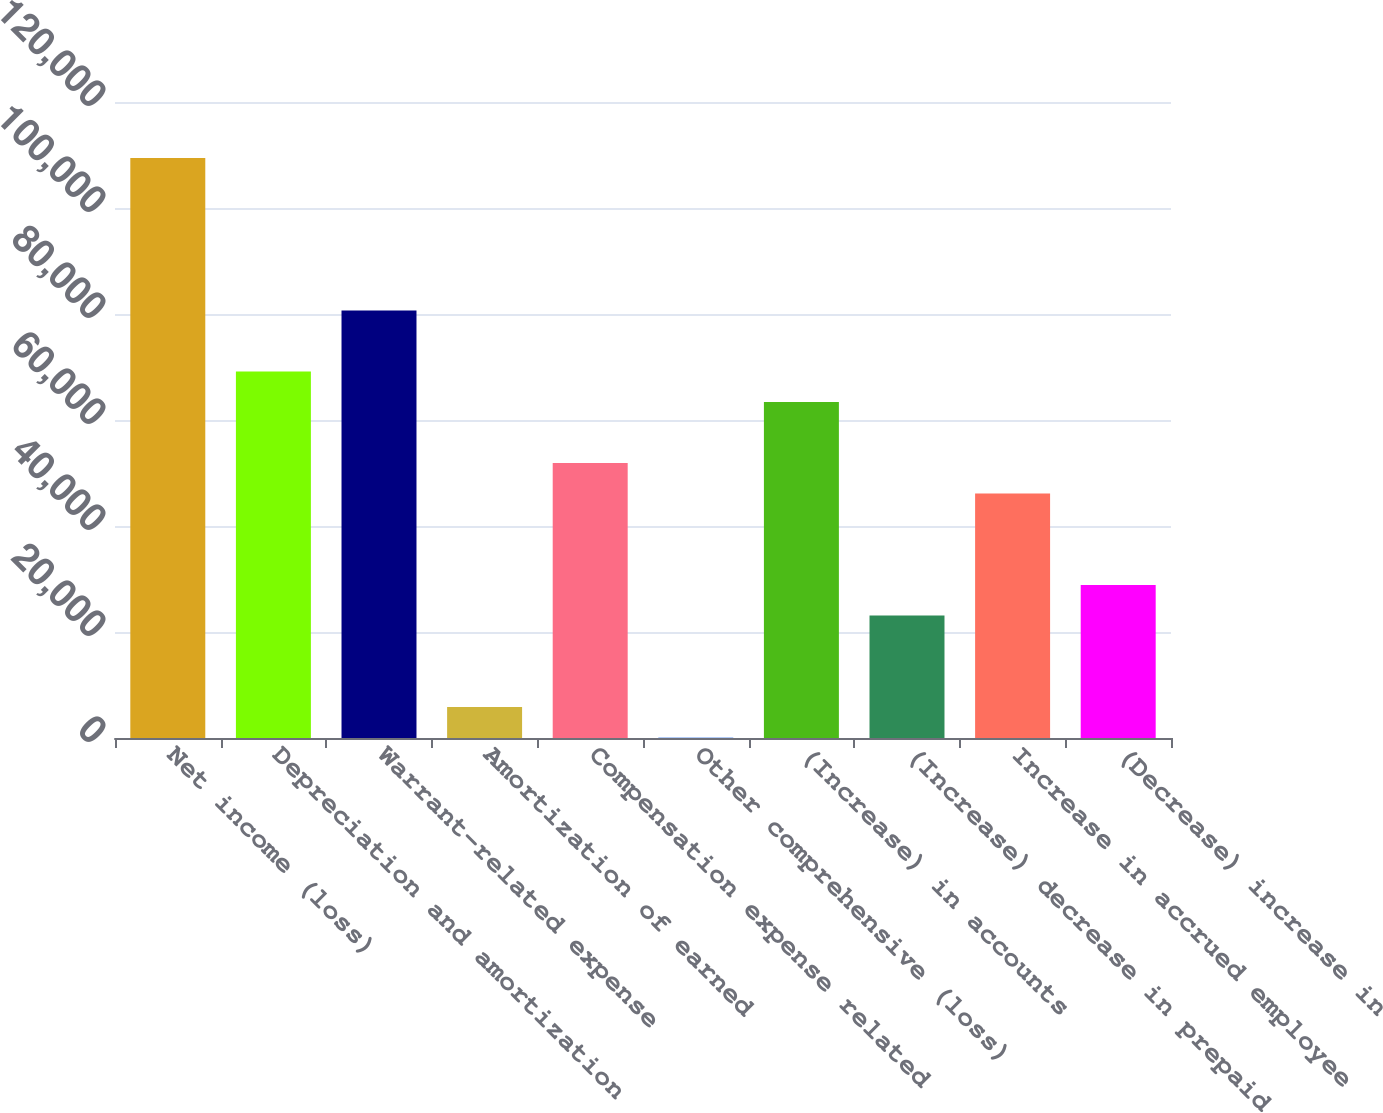Convert chart. <chart><loc_0><loc_0><loc_500><loc_500><bar_chart><fcel>Net income (loss)<fcel>Depreciation and amortization<fcel>Warrant-related expense<fcel>Amortization of earned<fcel>Compensation expense related<fcel>Other comprehensive (loss)<fcel>(Increase) in accounts<fcel>(Increase) decrease in prepaid<fcel>Increase in accrued employee<fcel>(Decrease) increase in<nl><fcel>109416<fcel>69131.8<fcel>80641.6<fcel>5827.9<fcel>51867.1<fcel>73<fcel>63376.9<fcel>23092.6<fcel>46112.2<fcel>28847.5<nl></chart> 